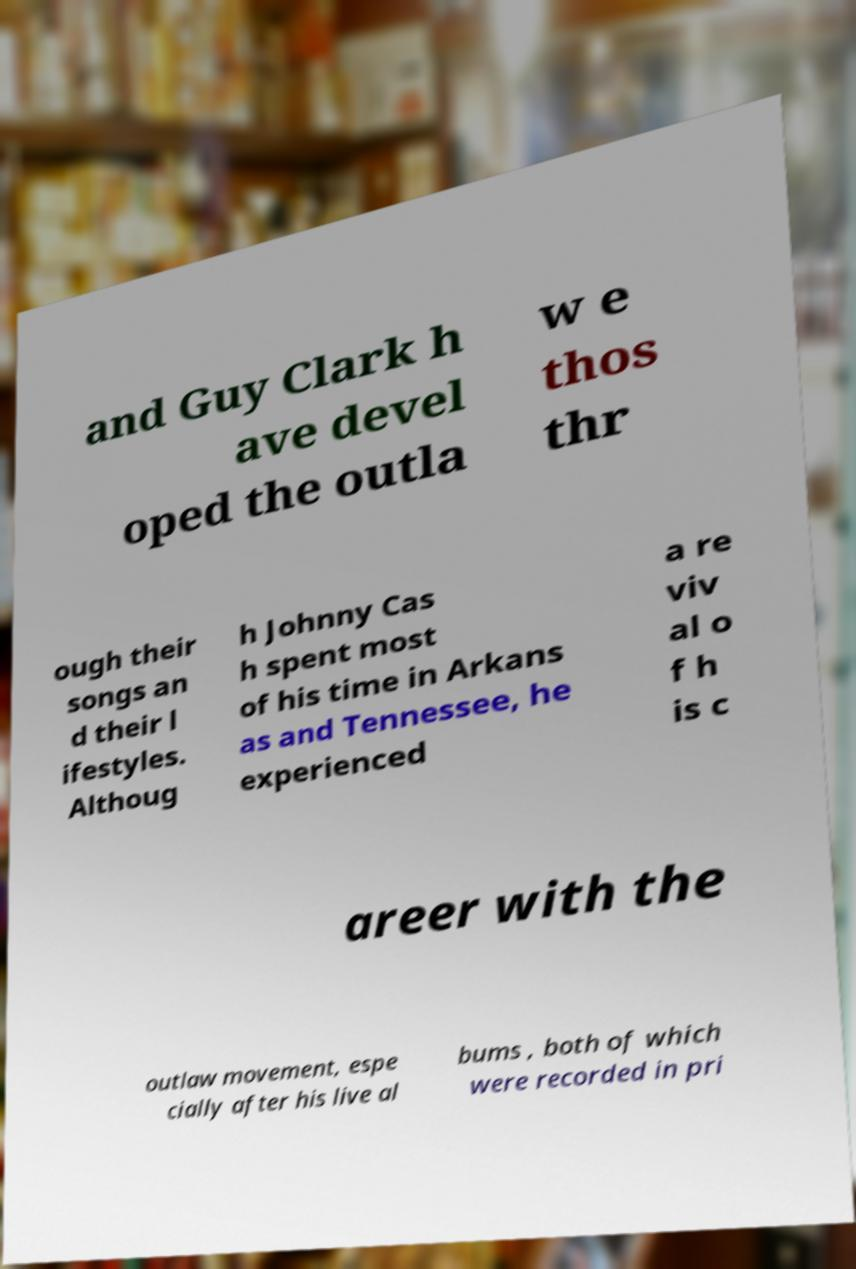For documentation purposes, I need the text within this image transcribed. Could you provide that? and Guy Clark h ave devel oped the outla w e thos thr ough their songs an d their l ifestyles. Althoug h Johnny Cas h spent most of his time in Arkans as and Tennessee, he experienced a re viv al o f h is c areer with the outlaw movement, espe cially after his live al bums , both of which were recorded in pri 